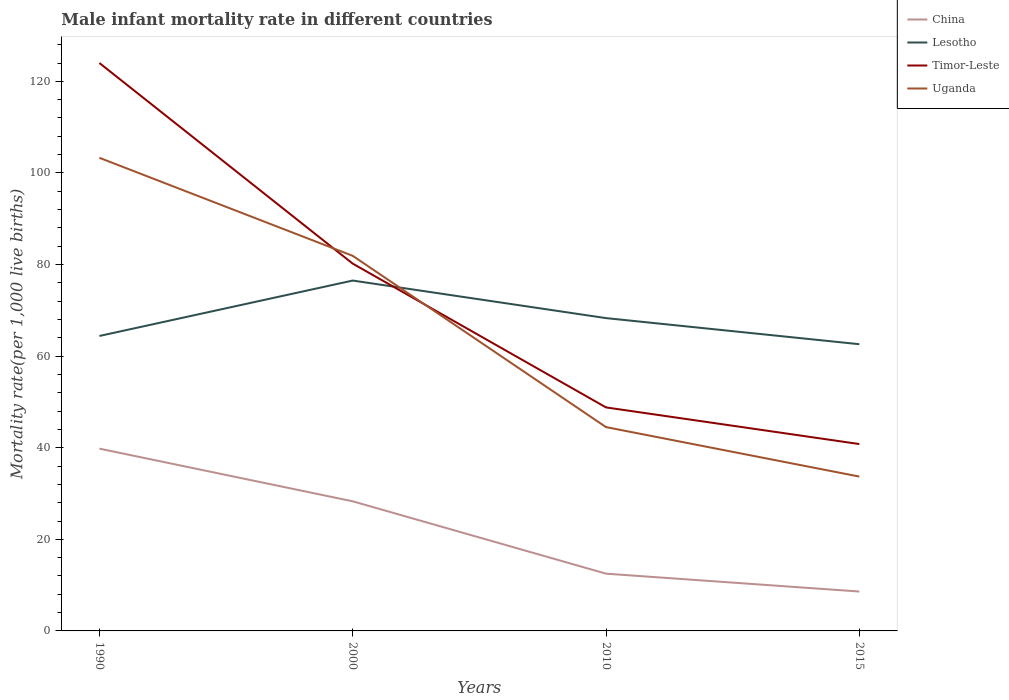Does the line corresponding to Uganda intersect with the line corresponding to Timor-Leste?
Your answer should be very brief. Yes. Is the number of lines equal to the number of legend labels?
Provide a short and direct response. Yes. Across all years, what is the maximum male infant mortality rate in Lesotho?
Give a very brief answer. 62.6. In which year was the male infant mortality rate in Lesotho maximum?
Offer a terse response. 2015. What is the total male infant mortality rate in Lesotho in the graph?
Your answer should be very brief. 5.7. What is the difference between the highest and the second highest male infant mortality rate in Timor-Leste?
Give a very brief answer. 83.2. Are the values on the major ticks of Y-axis written in scientific E-notation?
Keep it short and to the point. No. Does the graph contain any zero values?
Your answer should be compact. No. How are the legend labels stacked?
Offer a terse response. Vertical. What is the title of the graph?
Ensure brevity in your answer.  Male infant mortality rate in different countries. Does "Serbia" appear as one of the legend labels in the graph?
Offer a terse response. No. What is the label or title of the X-axis?
Offer a very short reply. Years. What is the label or title of the Y-axis?
Give a very brief answer. Mortality rate(per 1,0 live births). What is the Mortality rate(per 1,000 live births) in China in 1990?
Keep it short and to the point. 39.8. What is the Mortality rate(per 1,000 live births) in Lesotho in 1990?
Your answer should be very brief. 64.4. What is the Mortality rate(per 1,000 live births) in Timor-Leste in 1990?
Your answer should be compact. 124. What is the Mortality rate(per 1,000 live births) of Uganda in 1990?
Give a very brief answer. 103.3. What is the Mortality rate(per 1,000 live births) of China in 2000?
Your response must be concise. 28.3. What is the Mortality rate(per 1,000 live births) of Lesotho in 2000?
Your answer should be compact. 76.5. What is the Mortality rate(per 1,000 live births) of Timor-Leste in 2000?
Make the answer very short. 80.2. What is the Mortality rate(per 1,000 live births) in Uganda in 2000?
Your answer should be compact. 81.9. What is the Mortality rate(per 1,000 live births) in Lesotho in 2010?
Offer a very short reply. 68.3. What is the Mortality rate(per 1,000 live births) in Timor-Leste in 2010?
Give a very brief answer. 48.8. What is the Mortality rate(per 1,000 live births) in Uganda in 2010?
Provide a short and direct response. 44.5. What is the Mortality rate(per 1,000 live births) of Lesotho in 2015?
Offer a very short reply. 62.6. What is the Mortality rate(per 1,000 live births) of Timor-Leste in 2015?
Your response must be concise. 40.8. What is the Mortality rate(per 1,000 live births) in Uganda in 2015?
Keep it short and to the point. 33.7. Across all years, what is the maximum Mortality rate(per 1,000 live births) of China?
Your response must be concise. 39.8. Across all years, what is the maximum Mortality rate(per 1,000 live births) in Lesotho?
Give a very brief answer. 76.5. Across all years, what is the maximum Mortality rate(per 1,000 live births) of Timor-Leste?
Ensure brevity in your answer.  124. Across all years, what is the maximum Mortality rate(per 1,000 live births) of Uganda?
Provide a succinct answer. 103.3. Across all years, what is the minimum Mortality rate(per 1,000 live births) of Lesotho?
Ensure brevity in your answer.  62.6. Across all years, what is the minimum Mortality rate(per 1,000 live births) of Timor-Leste?
Give a very brief answer. 40.8. Across all years, what is the minimum Mortality rate(per 1,000 live births) of Uganda?
Your answer should be very brief. 33.7. What is the total Mortality rate(per 1,000 live births) of China in the graph?
Provide a succinct answer. 89.2. What is the total Mortality rate(per 1,000 live births) in Lesotho in the graph?
Provide a short and direct response. 271.8. What is the total Mortality rate(per 1,000 live births) in Timor-Leste in the graph?
Your answer should be compact. 293.8. What is the total Mortality rate(per 1,000 live births) in Uganda in the graph?
Make the answer very short. 263.4. What is the difference between the Mortality rate(per 1,000 live births) in Lesotho in 1990 and that in 2000?
Your answer should be compact. -12.1. What is the difference between the Mortality rate(per 1,000 live births) of Timor-Leste in 1990 and that in 2000?
Keep it short and to the point. 43.8. What is the difference between the Mortality rate(per 1,000 live births) of Uganda in 1990 and that in 2000?
Keep it short and to the point. 21.4. What is the difference between the Mortality rate(per 1,000 live births) of China in 1990 and that in 2010?
Ensure brevity in your answer.  27.3. What is the difference between the Mortality rate(per 1,000 live births) in Timor-Leste in 1990 and that in 2010?
Make the answer very short. 75.2. What is the difference between the Mortality rate(per 1,000 live births) in Uganda in 1990 and that in 2010?
Make the answer very short. 58.8. What is the difference between the Mortality rate(per 1,000 live births) of China in 1990 and that in 2015?
Provide a short and direct response. 31.2. What is the difference between the Mortality rate(per 1,000 live births) in Timor-Leste in 1990 and that in 2015?
Ensure brevity in your answer.  83.2. What is the difference between the Mortality rate(per 1,000 live births) in Uganda in 1990 and that in 2015?
Your answer should be compact. 69.6. What is the difference between the Mortality rate(per 1,000 live births) in Timor-Leste in 2000 and that in 2010?
Your response must be concise. 31.4. What is the difference between the Mortality rate(per 1,000 live births) of Uganda in 2000 and that in 2010?
Provide a short and direct response. 37.4. What is the difference between the Mortality rate(per 1,000 live births) of Timor-Leste in 2000 and that in 2015?
Make the answer very short. 39.4. What is the difference between the Mortality rate(per 1,000 live births) of Uganda in 2000 and that in 2015?
Offer a very short reply. 48.2. What is the difference between the Mortality rate(per 1,000 live births) of Lesotho in 2010 and that in 2015?
Give a very brief answer. 5.7. What is the difference between the Mortality rate(per 1,000 live births) in Uganda in 2010 and that in 2015?
Offer a very short reply. 10.8. What is the difference between the Mortality rate(per 1,000 live births) in China in 1990 and the Mortality rate(per 1,000 live births) in Lesotho in 2000?
Your answer should be very brief. -36.7. What is the difference between the Mortality rate(per 1,000 live births) in China in 1990 and the Mortality rate(per 1,000 live births) in Timor-Leste in 2000?
Give a very brief answer. -40.4. What is the difference between the Mortality rate(per 1,000 live births) in China in 1990 and the Mortality rate(per 1,000 live births) in Uganda in 2000?
Make the answer very short. -42.1. What is the difference between the Mortality rate(per 1,000 live births) of Lesotho in 1990 and the Mortality rate(per 1,000 live births) of Timor-Leste in 2000?
Your response must be concise. -15.8. What is the difference between the Mortality rate(per 1,000 live births) in Lesotho in 1990 and the Mortality rate(per 1,000 live births) in Uganda in 2000?
Your response must be concise. -17.5. What is the difference between the Mortality rate(per 1,000 live births) in Timor-Leste in 1990 and the Mortality rate(per 1,000 live births) in Uganda in 2000?
Offer a terse response. 42.1. What is the difference between the Mortality rate(per 1,000 live births) of China in 1990 and the Mortality rate(per 1,000 live births) of Lesotho in 2010?
Offer a terse response. -28.5. What is the difference between the Mortality rate(per 1,000 live births) of China in 1990 and the Mortality rate(per 1,000 live births) of Timor-Leste in 2010?
Provide a short and direct response. -9. What is the difference between the Mortality rate(per 1,000 live births) in China in 1990 and the Mortality rate(per 1,000 live births) in Uganda in 2010?
Your answer should be very brief. -4.7. What is the difference between the Mortality rate(per 1,000 live births) of Timor-Leste in 1990 and the Mortality rate(per 1,000 live births) of Uganda in 2010?
Your answer should be very brief. 79.5. What is the difference between the Mortality rate(per 1,000 live births) in China in 1990 and the Mortality rate(per 1,000 live births) in Lesotho in 2015?
Offer a very short reply. -22.8. What is the difference between the Mortality rate(per 1,000 live births) in China in 1990 and the Mortality rate(per 1,000 live births) in Uganda in 2015?
Ensure brevity in your answer.  6.1. What is the difference between the Mortality rate(per 1,000 live births) of Lesotho in 1990 and the Mortality rate(per 1,000 live births) of Timor-Leste in 2015?
Your answer should be very brief. 23.6. What is the difference between the Mortality rate(per 1,000 live births) in Lesotho in 1990 and the Mortality rate(per 1,000 live births) in Uganda in 2015?
Your response must be concise. 30.7. What is the difference between the Mortality rate(per 1,000 live births) in Timor-Leste in 1990 and the Mortality rate(per 1,000 live births) in Uganda in 2015?
Offer a terse response. 90.3. What is the difference between the Mortality rate(per 1,000 live births) in China in 2000 and the Mortality rate(per 1,000 live births) in Lesotho in 2010?
Keep it short and to the point. -40. What is the difference between the Mortality rate(per 1,000 live births) in China in 2000 and the Mortality rate(per 1,000 live births) in Timor-Leste in 2010?
Keep it short and to the point. -20.5. What is the difference between the Mortality rate(per 1,000 live births) in China in 2000 and the Mortality rate(per 1,000 live births) in Uganda in 2010?
Your answer should be compact. -16.2. What is the difference between the Mortality rate(per 1,000 live births) of Lesotho in 2000 and the Mortality rate(per 1,000 live births) of Timor-Leste in 2010?
Provide a succinct answer. 27.7. What is the difference between the Mortality rate(per 1,000 live births) in Timor-Leste in 2000 and the Mortality rate(per 1,000 live births) in Uganda in 2010?
Keep it short and to the point. 35.7. What is the difference between the Mortality rate(per 1,000 live births) in China in 2000 and the Mortality rate(per 1,000 live births) in Lesotho in 2015?
Your response must be concise. -34.3. What is the difference between the Mortality rate(per 1,000 live births) of China in 2000 and the Mortality rate(per 1,000 live births) of Uganda in 2015?
Keep it short and to the point. -5.4. What is the difference between the Mortality rate(per 1,000 live births) in Lesotho in 2000 and the Mortality rate(per 1,000 live births) in Timor-Leste in 2015?
Offer a terse response. 35.7. What is the difference between the Mortality rate(per 1,000 live births) of Lesotho in 2000 and the Mortality rate(per 1,000 live births) of Uganda in 2015?
Provide a short and direct response. 42.8. What is the difference between the Mortality rate(per 1,000 live births) of Timor-Leste in 2000 and the Mortality rate(per 1,000 live births) of Uganda in 2015?
Provide a short and direct response. 46.5. What is the difference between the Mortality rate(per 1,000 live births) in China in 2010 and the Mortality rate(per 1,000 live births) in Lesotho in 2015?
Make the answer very short. -50.1. What is the difference between the Mortality rate(per 1,000 live births) in China in 2010 and the Mortality rate(per 1,000 live births) in Timor-Leste in 2015?
Offer a very short reply. -28.3. What is the difference between the Mortality rate(per 1,000 live births) of China in 2010 and the Mortality rate(per 1,000 live births) of Uganda in 2015?
Keep it short and to the point. -21.2. What is the difference between the Mortality rate(per 1,000 live births) in Lesotho in 2010 and the Mortality rate(per 1,000 live births) in Timor-Leste in 2015?
Ensure brevity in your answer.  27.5. What is the difference between the Mortality rate(per 1,000 live births) in Lesotho in 2010 and the Mortality rate(per 1,000 live births) in Uganda in 2015?
Offer a very short reply. 34.6. What is the difference between the Mortality rate(per 1,000 live births) of Timor-Leste in 2010 and the Mortality rate(per 1,000 live births) of Uganda in 2015?
Offer a very short reply. 15.1. What is the average Mortality rate(per 1,000 live births) in China per year?
Your response must be concise. 22.3. What is the average Mortality rate(per 1,000 live births) of Lesotho per year?
Provide a succinct answer. 67.95. What is the average Mortality rate(per 1,000 live births) of Timor-Leste per year?
Your answer should be very brief. 73.45. What is the average Mortality rate(per 1,000 live births) of Uganda per year?
Offer a very short reply. 65.85. In the year 1990, what is the difference between the Mortality rate(per 1,000 live births) in China and Mortality rate(per 1,000 live births) in Lesotho?
Your answer should be compact. -24.6. In the year 1990, what is the difference between the Mortality rate(per 1,000 live births) in China and Mortality rate(per 1,000 live births) in Timor-Leste?
Your response must be concise. -84.2. In the year 1990, what is the difference between the Mortality rate(per 1,000 live births) of China and Mortality rate(per 1,000 live births) of Uganda?
Provide a short and direct response. -63.5. In the year 1990, what is the difference between the Mortality rate(per 1,000 live births) of Lesotho and Mortality rate(per 1,000 live births) of Timor-Leste?
Your response must be concise. -59.6. In the year 1990, what is the difference between the Mortality rate(per 1,000 live births) of Lesotho and Mortality rate(per 1,000 live births) of Uganda?
Give a very brief answer. -38.9. In the year 1990, what is the difference between the Mortality rate(per 1,000 live births) in Timor-Leste and Mortality rate(per 1,000 live births) in Uganda?
Provide a short and direct response. 20.7. In the year 2000, what is the difference between the Mortality rate(per 1,000 live births) of China and Mortality rate(per 1,000 live births) of Lesotho?
Make the answer very short. -48.2. In the year 2000, what is the difference between the Mortality rate(per 1,000 live births) in China and Mortality rate(per 1,000 live births) in Timor-Leste?
Ensure brevity in your answer.  -51.9. In the year 2000, what is the difference between the Mortality rate(per 1,000 live births) of China and Mortality rate(per 1,000 live births) of Uganda?
Your response must be concise. -53.6. In the year 2000, what is the difference between the Mortality rate(per 1,000 live births) of Lesotho and Mortality rate(per 1,000 live births) of Timor-Leste?
Give a very brief answer. -3.7. In the year 2010, what is the difference between the Mortality rate(per 1,000 live births) in China and Mortality rate(per 1,000 live births) in Lesotho?
Ensure brevity in your answer.  -55.8. In the year 2010, what is the difference between the Mortality rate(per 1,000 live births) of China and Mortality rate(per 1,000 live births) of Timor-Leste?
Ensure brevity in your answer.  -36.3. In the year 2010, what is the difference between the Mortality rate(per 1,000 live births) of China and Mortality rate(per 1,000 live births) of Uganda?
Your response must be concise. -32. In the year 2010, what is the difference between the Mortality rate(per 1,000 live births) of Lesotho and Mortality rate(per 1,000 live births) of Timor-Leste?
Make the answer very short. 19.5. In the year 2010, what is the difference between the Mortality rate(per 1,000 live births) of Lesotho and Mortality rate(per 1,000 live births) of Uganda?
Provide a succinct answer. 23.8. In the year 2010, what is the difference between the Mortality rate(per 1,000 live births) of Timor-Leste and Mortality rate(per 1,000 live births) of Uganda?
Your response must be concise. 4.3. In the year 2015, what is the difference between the Mortality rate(per 1,000 live births) in China and Mortality rate(per 1,000 live births) in Lesotho?
Your answer should be very brief. -54. In the year 2015, what is the difference between the Mortality rate(per 1,000 live births) of China and Mortality rate(per 1,000 live births) of Timor-Leste?
Give a very brief answer. -32.2. In the year 2015, what is the difference between the Mortality rate(per 1,000 live births) in China and Mortality rate(per 1,000 live births) in Uganda?
Give a very brief answer. -25.1. In the year 2015, what is the difference between the Mortality rate(per 1,000 live births) in Lesotho and Mortality rate(per 1,000 live births) in Timor-Leste?
Provide a succinct answer. 21.8. In the year 2015, what is the difference between the Mortality rate(per 1,000 live births) in Lesotho and Mortality rate(per 1,000 live births) in Uganda?
Offer a very short reply. 28.9. What is the ratio of the Mortality rate(per 1,000 live births) in China in 1990 to that in 2000?
Keep it short and to the point. 1.41. What is the ratio of the Mortality rate(per 1,000 live births) of Lesotho in 1990 to that in 2000?
Your answer should be compact. 0.84. What is the ratio of the Mortality rate(per 1,000 live births) in Timor-Leste in 1990 to that in 2000?
Make the answer very short. 1.55. What is the ratio of the Mortality rate(per 1,000 live births) in Uganda in 1990 to that in 2000?
Give a very brief answer. 1.26. What is the ratio of the Mortality rate(per 1,000 live births) in China in 1990 to that in 2010?
Offer a very short reply. 3.18. What is the ratio of the Mortality rate(per 1,000 live births) of Lesotho in 1990 to that in 2010?
Provide a succinct answer. 0.94. What is the ratio of the Mortality rate(per 1,000 live births) of Timor-Leste in 1990 to that in 2010?
Offer a terse response. 2.54. What is the ratio of the Mortality rate(per 1,000 live births) of Uganda in 1990 to that in 2010?
Ensure brevity in your answer.  2.32. What is the ratio of the Mortality rate(per 1,000 live births) in China in 1990 to that in 2015?
Provide a short and direct response. 4.63. What is the ratio of the Mortality rate(per 1,000 live births) of Lesotho in 1990 to that in 2015?
Make the answer very short. 1.03. What is the ratio of the Mortality rate(per 1,000 live births) of Timor-Leste in 1990 to that in 2015?
Offer a very short reply. 3.04. What is the ratio of the Mortality rate(per 1,000 live births) in Uganda in 1990 to that in 2015?
Your response must be concise. 3.07. What is the ratio of the Mortality rate(per 1,000 live births) of China in 2000 to that in 2010?
Your answer should be compact. 2.26. What is the ratio of the Mortality rate(per 1,000 live births) of Lesotho in 2000 to that in 2010?
Give a very brief answer. 1.12. What is the ratio of the Mortality rate(per 1,000 live births) in Timor-Leste in 2000 to that in 2010?
Provide a succinct answer. 1.64. What is the ratio of the Mortality rate(per 1,000 live births) of Uganda in 2000 to that in 2010?
Your response must be concise. 1.84. What is the ratio of the Mortality rate(per 1,000 live births) of China in 2000 to that in 2015?
Provide a short and direct response. 3.29. What is the ratio of the Mortality rate(per 1,000 live births) of Lesotho in 2000 to that in 2015?
Your answer should be compact. 1.22. What is the ratio of the Mortality rate(per 1,000 live births) in Timor-Leste in 2000 to that in 2015?
Offer a very short reply. 1.97. What is the ratio of the Mortality rate(per 1,000 live births) of Uganda in 2000 to that in 2015?
Your answer should be very brief. 2.43. What is the ratio of the Mortality rate(per 1,000 live births) in China in 2010 to that in 2015?
Offer a very short reply. 1.45. What is the ratio of the Mortality rate(per 1,000 live births) in Lesotho in 2010 to that in 2015?
Keep it short and to the point. 1.09. What is the ratio of the Mortality rate(per 1,000 live births) in Timor-Leste in 2010 to that in 2015?
Your response must be concise. 1.2. What is the ratio of the Mortality rate(per 1,000 live births) of Uganda in 2010 to that in 2015?
Provide a succinct answer. 1.32. What is the difference between the highest and the second highest Mortality rate(per 1,000 live births) in China?
Provide a short and direct response. 11.5. What is the difference between the highest and the second highest Mortality rate(per 1,000 live births) of Lesotho?
Your answer should be very brief. 8.2. What is the difference between the highest and the second highest Mortality rate(per 1,000 live births) in Timor-Leste?
Provide a short and direct response. 43.8. What is the difference between the highest and the second highest Mortality rate(per 1,000 live births) in Uganda?
Keep it short and to the point. 21.4. What is the difference between the highest and the lowest Mortality rate(per 1,000 live births) of China?
Make the answer very short. 31.2. What is the difference between the highest and the lowest Mortality rate(per 1,000 live births) in Timor-Leste?
Your answer should be compact. 83.2. What is the difference between the highest and the lowest Mortality rate(per 1,000 live births) in Uganda?
Give a very brief answer. 69.6. 